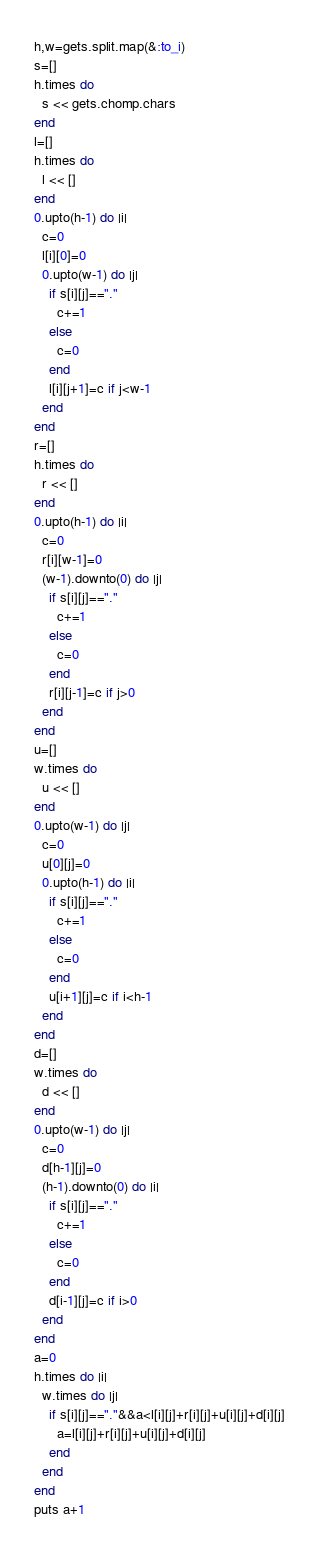Convert code to text. <code><loc_0><loc_0><loc_500><loc_500><_Ruby_>h,w=gets.split.map(&:to_i)
s=[]
h.times do
  s << gets.chomp.chars
end
l=[]
h.times do
  l << []
end
0.upto(h-1) do |i|
  c=0
  l[i][0]=0
  0.upto(w-1) do |j|
    if s[i][j]=="."
      c+=1
    else
      c=0
    end
    l[i][j+1]=c if j<w-1
  end
end
r=[]
h.times do
  r << []
end
0.upto(h-1) do |i|
  c=0
  r[i][w-1]=0
  (w-1).downto(0) do |j|
    if s[i][j]=="."
      c+=1
    else
      c=0
    end
    r[i][j-1]=c if j>0
  end
end
u=[]
w.times do
  u << []
end
0.upto(w-1) do |j|
  c=0
  u[0][j]=0
  0.upto(h-1) do |i|
    if s[i][j]=="."
      c+=1
    else
      c=0
    end
    u[i+1][j]=c if i<h-1
  end
end
d=[]
w.times do
  d << []
end
0.upto(w-1) do |j|
  c=0
  d[h-1][j]=0
  (h-1).downto(0) do |i|
    if s[i][j]=="."
      c+=1
    else
      c=0
    end
    d[i-1][j]=c if i>0
  end
end
a=0
h.times do |i|
  w.times do |j|
    if s[i][j]=="."&&a<l[i][j]+r[i][j]+u[i][j]+d[i][j]
      a=l[i][j]+r[i][j]+u[i][j]+d[i][j]
    end
  end
end
puts a+1
</code> 